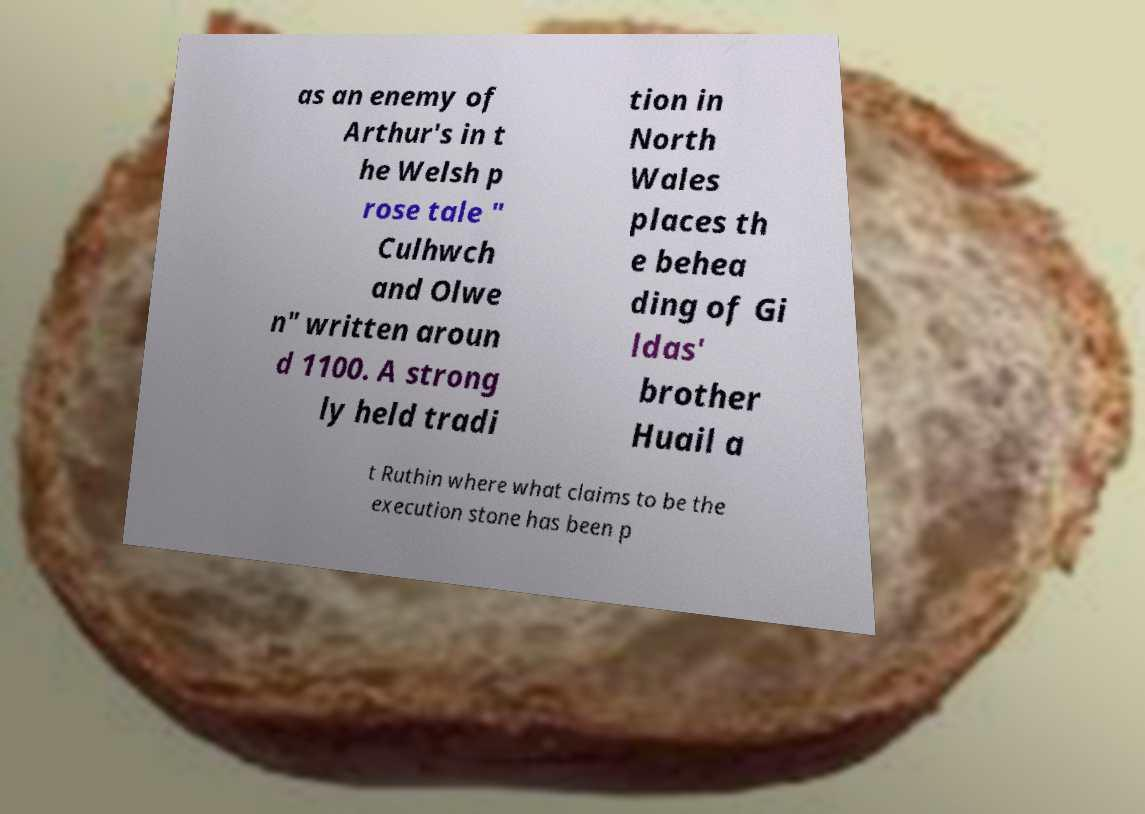Please read and relay the text visible in this image. What does it say? as an enemy of Arthur's in t he Welsh p rose tale " Culhwch and Olwe n" written aroun d 1100. A strong ly held tradi tion in North Wales places th e behea ding of Gi ldas' brother Huail a t Ruthin where what claims to be the execution stone has been p 